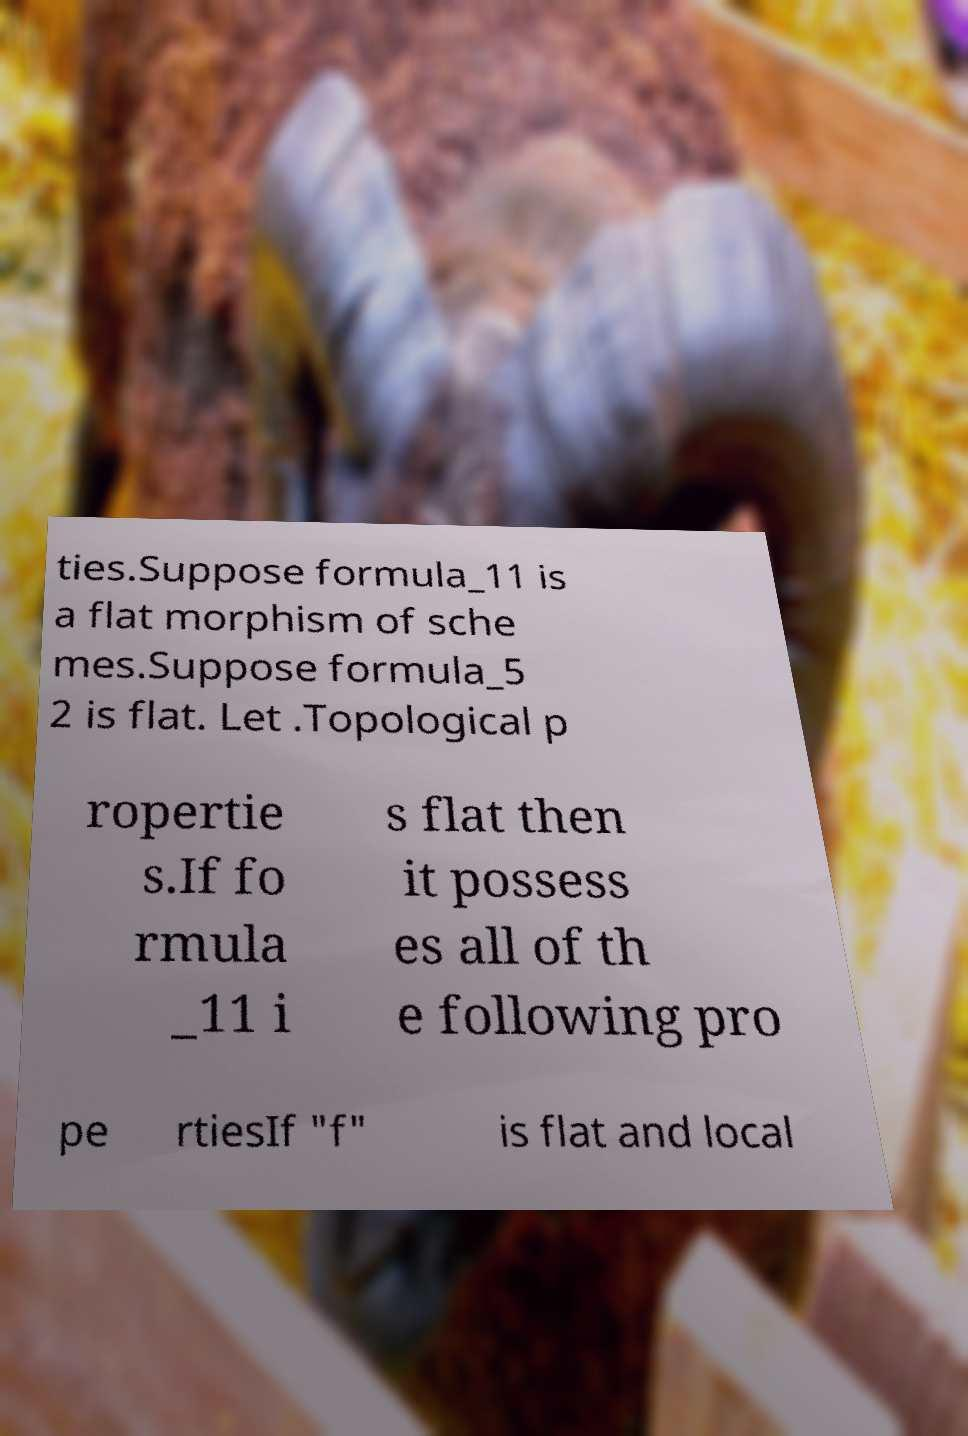Can you read and provide the text displayed in the image?This photo seems to have some interesting text. Can you extract and type it out for me? ties.Suppose formula_11 is a flat morphism of sche mes.Suppose formula_5 2 is flat. Let .Topological p ropertie s.If fo rmula _11 i s flat then it possess es all of th e following pro pe rtiesIf "f" is flat and local 